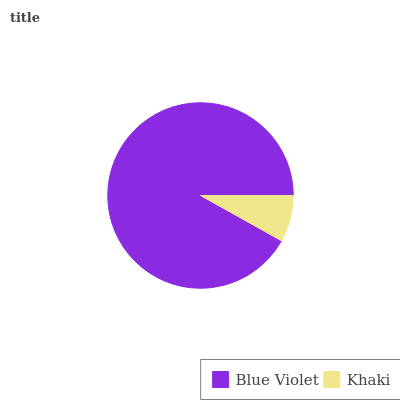Is Khaki the minimum?
Answer yes or no. Yes. Is Blue Violet the maximum?
Answer yes or no. Yes. Is Khaki the maximum?
Answer yes or no. No. Is Blue Violet greater than Khaki?
Answer yes or no. Yes. Is Khaki less than Blue Violet?
Answer yes or no. Yes. Is Khaki greater than Blue Violet?
Answer yes or no. No. Is Blue Violet less than Khaki?
Answer yes or no. No. Is Blue Violet the high median?
Answer yes or no. Yes. Is Khaki the low median?
Answer yes or no. Yes. Is Khaki the high median?
Answer yes or no. No. Is Blue Violet the low median?
Answer yes or no. No. 